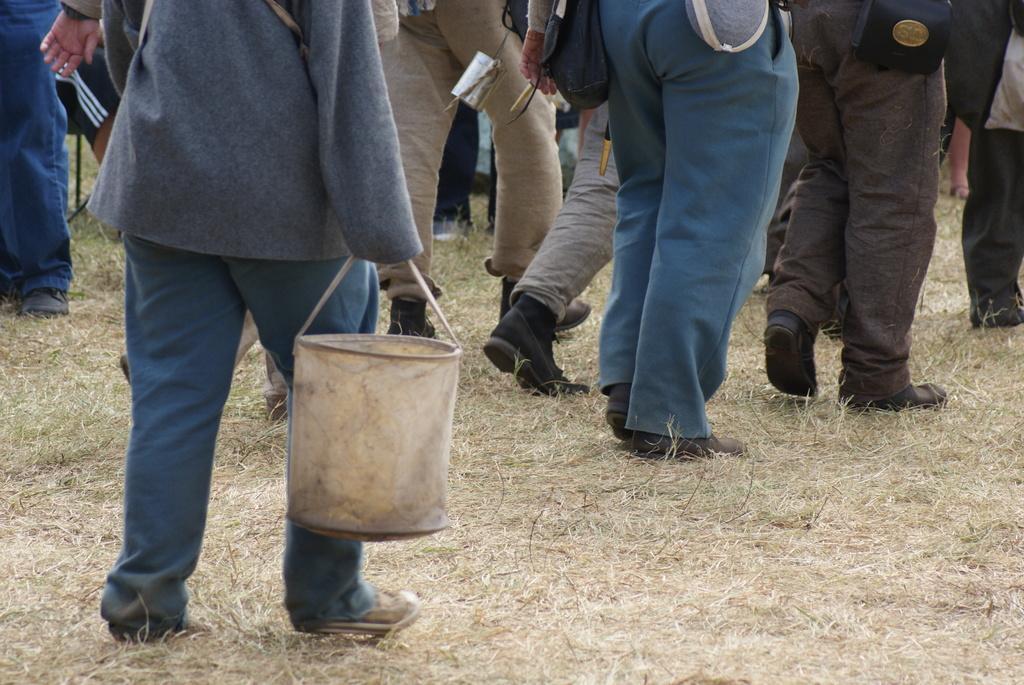Can you describe this image briefly? In this picture it looks like a person holding a bag and standing on the grass. In the background there are many people standing on the grass. 